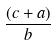Convert formula to latex. <formula><loc_0><loc_0><loc_500><loc_500>\frac { ( c + a ) } { b }</formula> 